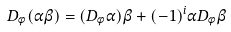Convert formula to latex. <formula><loc_0><loc_0><loc_500><loc_500>D _ { \phi } ( \alpha \beta ) = ( D _ { \phi } \alpha ) \beta + ( - 1 ) ^ { i } \alpha D _ { \phi } \beta</formula> 